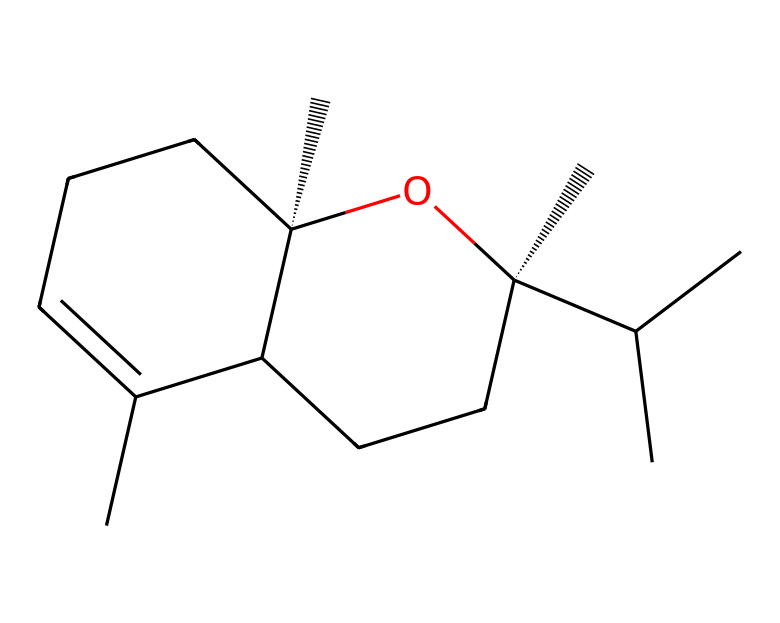How many carbon atoms are present in beta-caryophyllene? By analyzing the SMILES structure, we can count the number of carbon atoms (C). Each uppercase 'C' in the SMILES represents one carbon atom, and by counting we find that there are 15 carbon atoms in the structure.
Answer: 15 What type of functional group is present in beta-caryophyllene? The presence of the -OH group in the structure indicates there is an alcohol functional group. This can be identified by finding the oxygen connected to a carbon atom and also attached to a hydrogen atom.
Answer: alcohol What is the stereochemistry of benzocyclohexane in this compound? The structure contains two stereocenters, indicated by the '@' symbols in the SMILES representation. The configuration around these centers defines the stereochemistry, which for this compound is (1S,4S).
Answer: (1S,4S) How many rings are present in the structure of beta-caryophyllene? Upon examining the skeletal structure implied by the SMILES, we can identify the rings formed by analyzing the segments of the structure and counting the circular connections. In this case, there are two rings in beta-caryophyllene.
Answer: 2 Is beta-caryophyllene a monocyclic or polycyclic compound? A polycyclic compound contains two or more interconnected rings, while a monocyclic compound has only one ring. Since beta-caryophyllene contains two rings that are fused together, it is classified as polycyclic.
Answer: polycyclic What is the molecular formula for beta-caryophyllene? By deducing the number of each type of atom in the structure from the SMILES (15 carbons, 24 hydrogens, and 1 oxygen), we can construct the molecular formula. Thus, the molecular formula is C15H24O.
Answer: C15H24O 